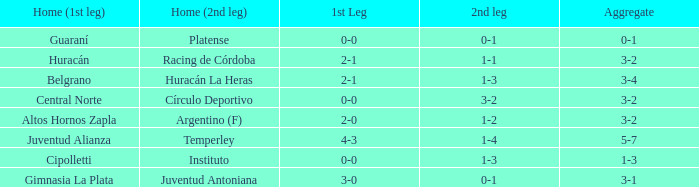What was the aggregate score that had a 1-2 second leg score? 3-2. 